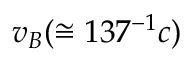<formula> <loc_0><loc_0><loc_500><loc_500>v _ { B } ( \cong 1 3 7 ^ { - 1 } c )</formula> 